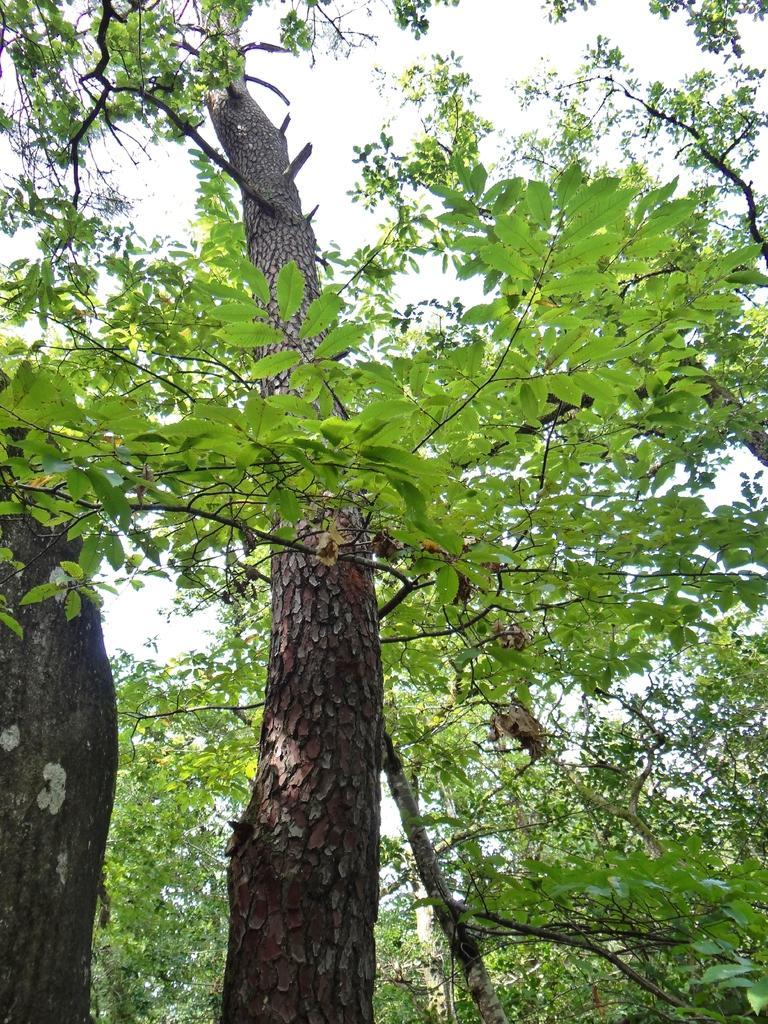Could you give a brief overview of what you see in this image? In this picture I can see few trees in the middle, at the top there is the sky. 